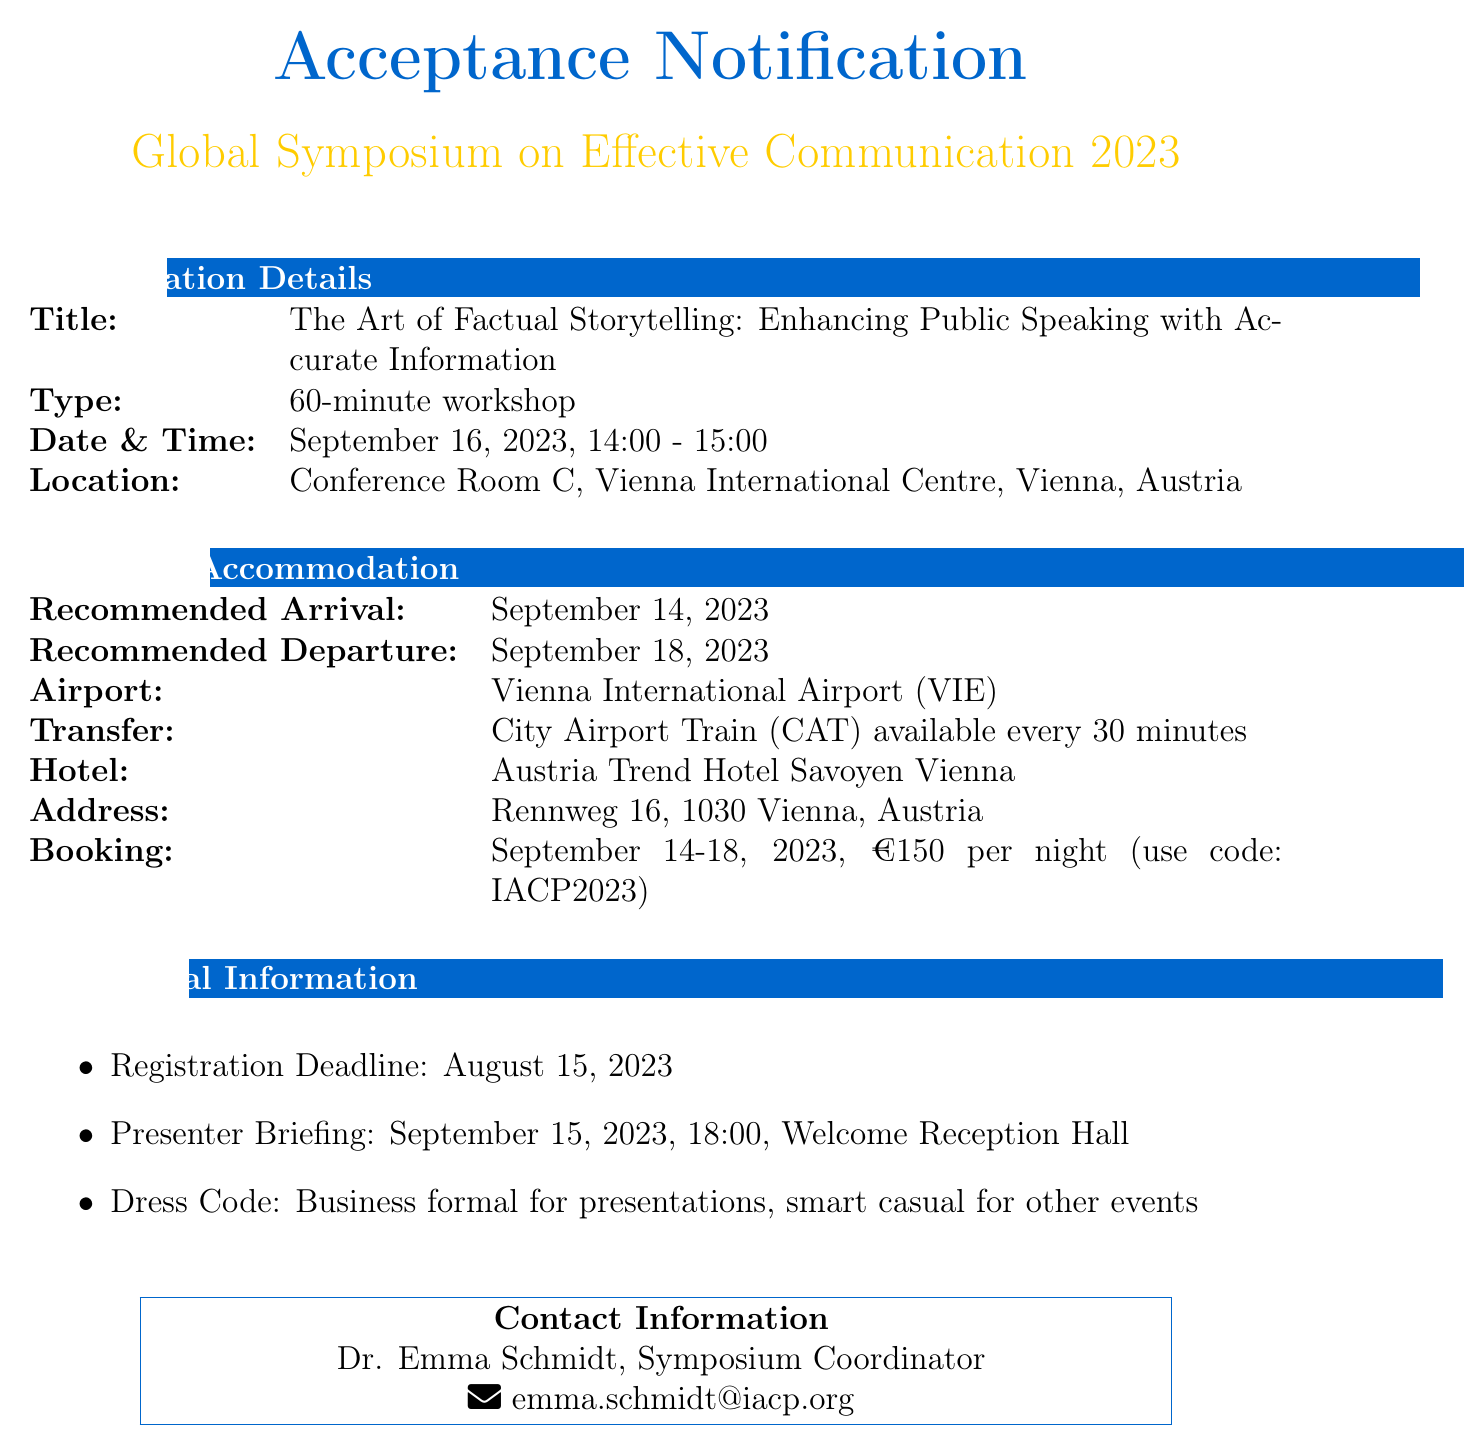What is the name of the symposium? The name of the symposium is stated in the document under symposium details.
Answer: Global Symposium on Effective Communication 2023 What is the presentation title? The presentation title is provided in the acceptance information section of the document.
Answer: The Art of Factual Storytelling: Enhancing Public Speaking with Accurate Information When is the presenter briefing scheduled? The document includes the date and time for the presenter briefing in the additional information section.
Answer: September 15, 2023, 18:00 What is the recommended arrival date? The recommended arrival date is mentioned under travel arrangements.
Answer: September 14, 2023 What is the special rate for accommodation? The special rate for attendees is listed in the accommodation section.
Answer: €150 per night Which airport is nearest to the venue? The nearest airport is specified in the travel arrangements section of the document.
Answer: Vienna International Airport (VIE) What is the dress code for presentations? The dress code for presentations is detailed in the additional information section.
Answer: Business formal What is the recommended departure date? The recommended departure date is given in the travel arrangements portion of the document.
Answer: September 18, 2023 